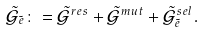<formula> <loc_0><loc_0><loc_500><loc_500>\tilde { \mathcal { G } } _ { \tilde { e } } \colon = \tilde { \mathcal { G } } ^ { r e s } + \tilde { \mathcal { G } } ^ { m u t } + \tilde { \mathcal { G } } _ { \tilde { e } } ^ { s e l } .</formula> 